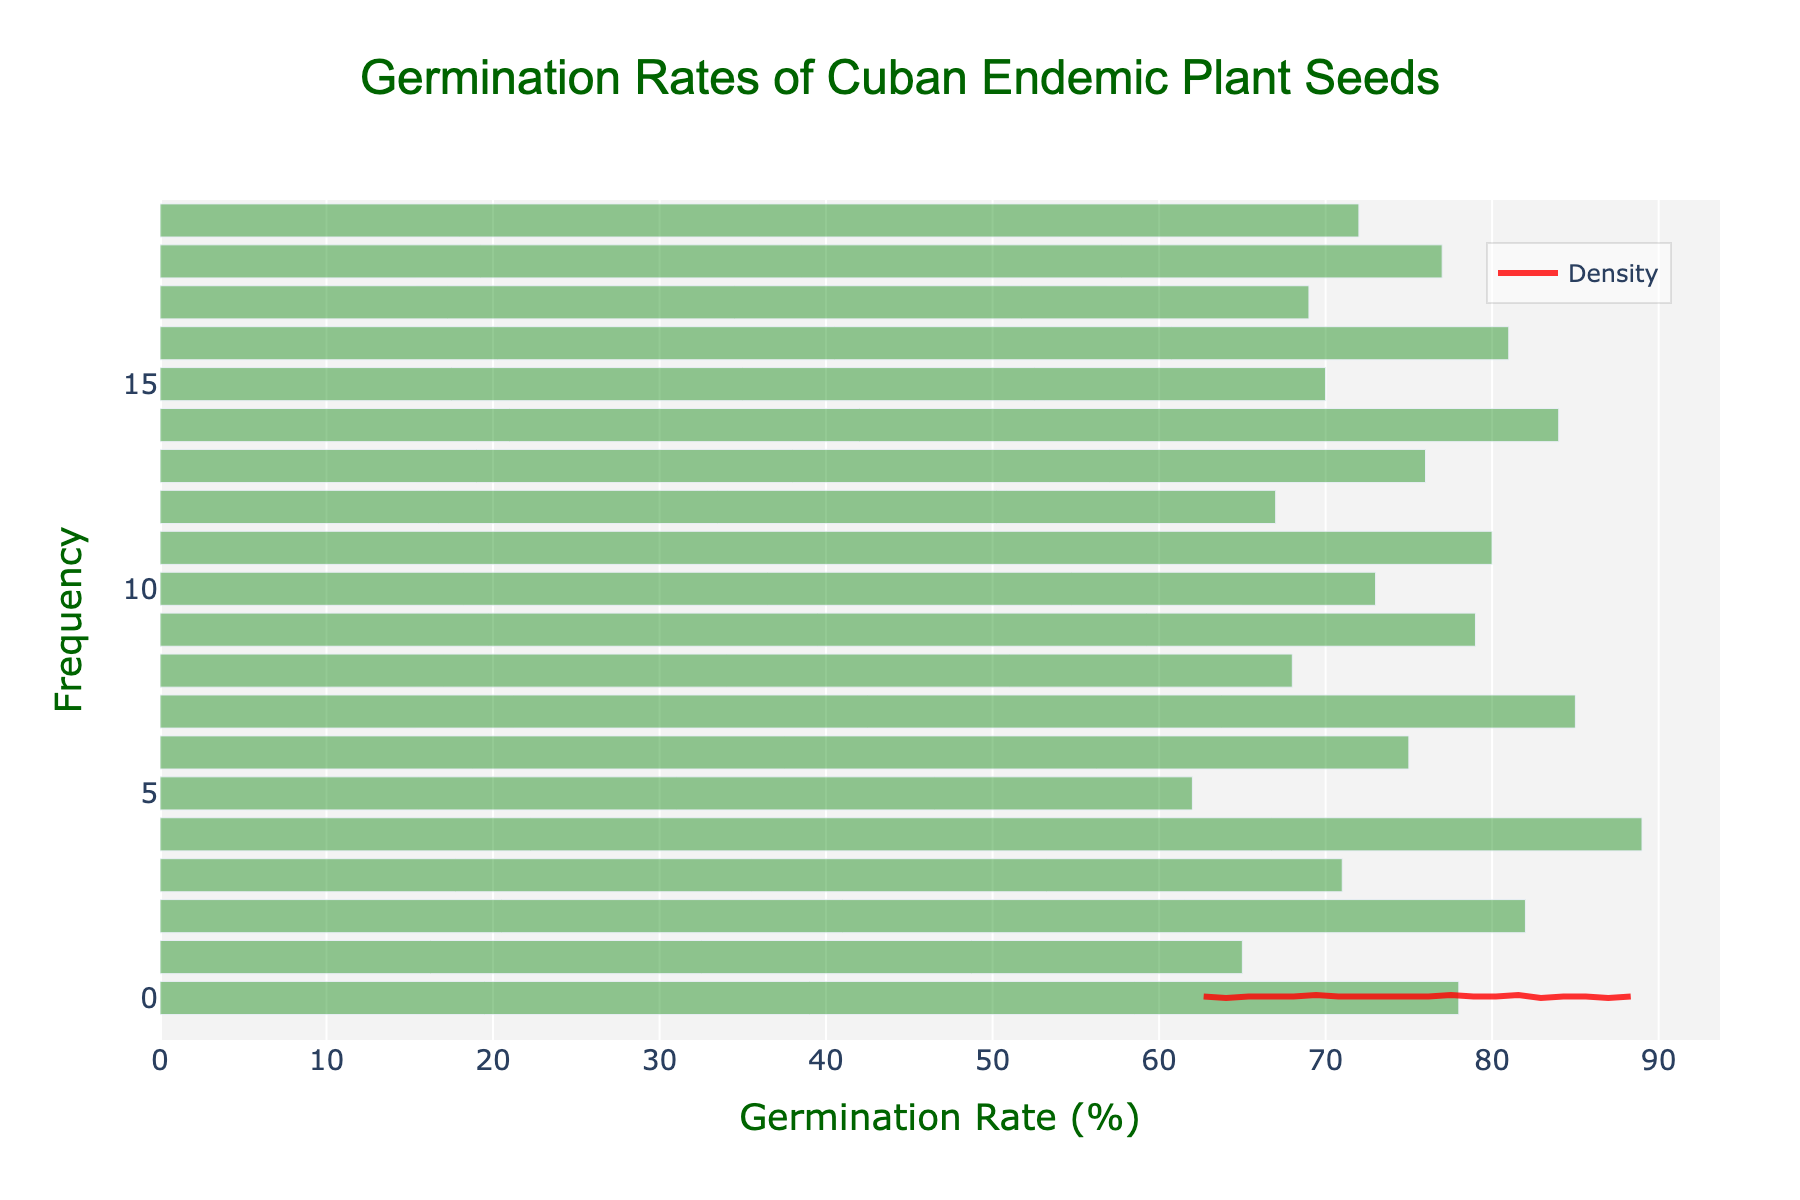What is the title of the figure? The title is found at the top center of the figure; it reads 'Germination Rates of Cuban Endemic Plant Seeds'.
Answer: Germination Rates of Cuban Endemic Plant Seeds What are the axes titles in the figure? The x-axis title is 'Germination Rate (%)' and the y-axis title is 'Frequency'. These are located on the x and y axes respectively.
Answer: Germination Rate (%) (x) and Frequency (y) What is the color of the histogram bars? The histogram bars are green with some transparency, as indicated in the visual representation.
Answer: Green Which plant species has the highest germination rate? By observing the histogram, the tallest bar represents the Cuban Oak which corresponds to the highest germination rate of 89%.
Answer: Cuban Oak How many plant species have a germination rate above 80%? Reviewing the histogram bars above the 80% threshold, the species with germination rates of 82%, 84%, 85%, 89%, and 81% are counted. This means there are 5 species.
Answer: 5 Which germination rate has the highest density as shown by the KDE curve? The peak of the KDE curve identifies the highest density, which occurs around the germination rate of approximately 75%.
Answer: Approximately 75% What is the range of germination rates in the figure? By examining the spread of the histogram bars, the minimum rate is 62% and the maximum rate is 89%. The range is calculated as 89% - 62%.
Answer: 27% Which has higher density on the KDE curve, germination rate of 70% or 80%? Comparing the KDE curve values at 70% and 80%, the point at 80% is higher, indicating greater density.
Answer: 80% What is the average germination rate of all plant species in the dataset? By calculating the mean of all germination rates: (78 + 65 + 82 + 71 + 89 + 62 + 75 + 85 + 68 + 79 + 73 + 80 + 67 + 76 + 84 + 70 + 81 + 69 + 77 + 72) / 20 = 74
Answer: 74% How does the histogram change in frequency as germination rate increases? Observing the histogram, initially the frequency is lower at the lower germination rates, increases around mid-range (~70%-80%) and then reduces again at higher germination rates.
Answer: Increases then decreases 